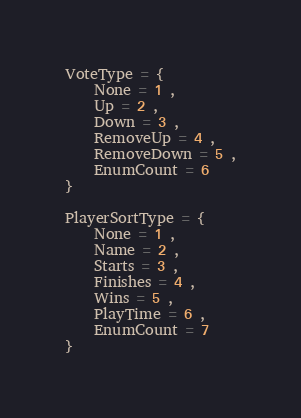<code> <loc_0><loc_0><loc_500><loc_500><_Lua_>VoteType = {
	None = 1 ,
	Up = 2 ,
	Down = 3 ,
	RemoveUp = 4 ,
	RemoveDown = 5 ,
	EnumCount = 6
}

PlayerSortType = {
	None = 1 ,
	Name = 2 ,
	Starts = 3 ,
	Finishes = 4 ,
	Wins = 5 ,
	PlayTime = 6 ,
	EnumCount = 7
}
</code> 